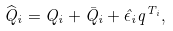<formula> <loc_0><loc_0><loc_500><loc_500>\widehat { Q } _ { i } = Q _ { i } + \bar { Q } _ { i } + \hat { \epsilon } _ { i } q ^ { T _ { i } } ,</formula> 